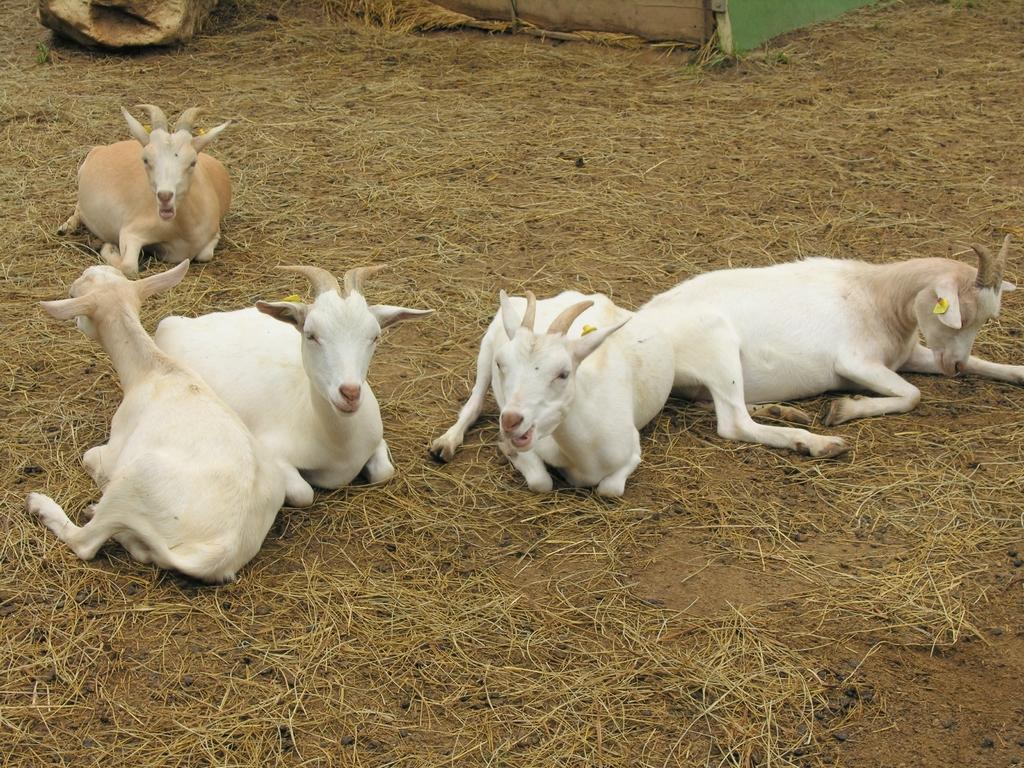What type of animals are in the image? There are white and cream color goats in the image. What is the position of the goats in the image? The goats are sitting on the land. What can be seen on the land where the goats are sitting? There is dried grass on the land. What is the goats' reason for participating in the protest in the image? There is no protest present in the image, so the goats have no reason to participate in one. 